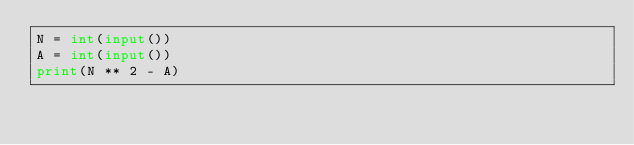<code> <loc_0><loc_0><loc_500><loc_500><_Python_>N = int(input())
A = int(input())
print(N ** 2 - A)</code> 